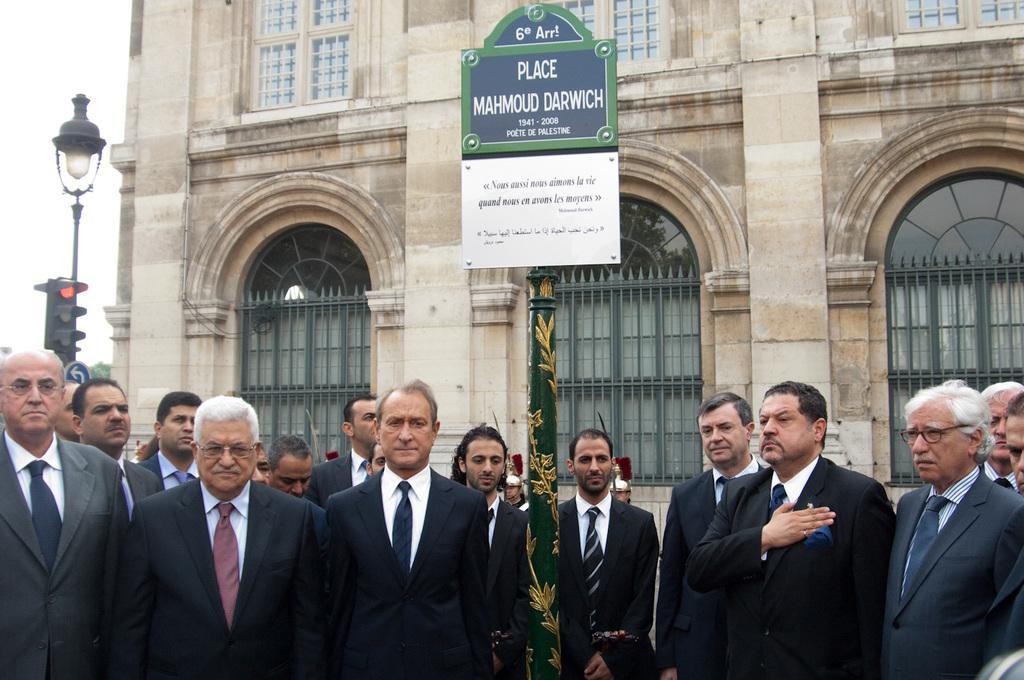Describe this image in one or two sentences. There is a historical Landmark of a poet and a group of men are paying respect to the poet in that place,behind the man there is a traffic signal pole and a street light. 